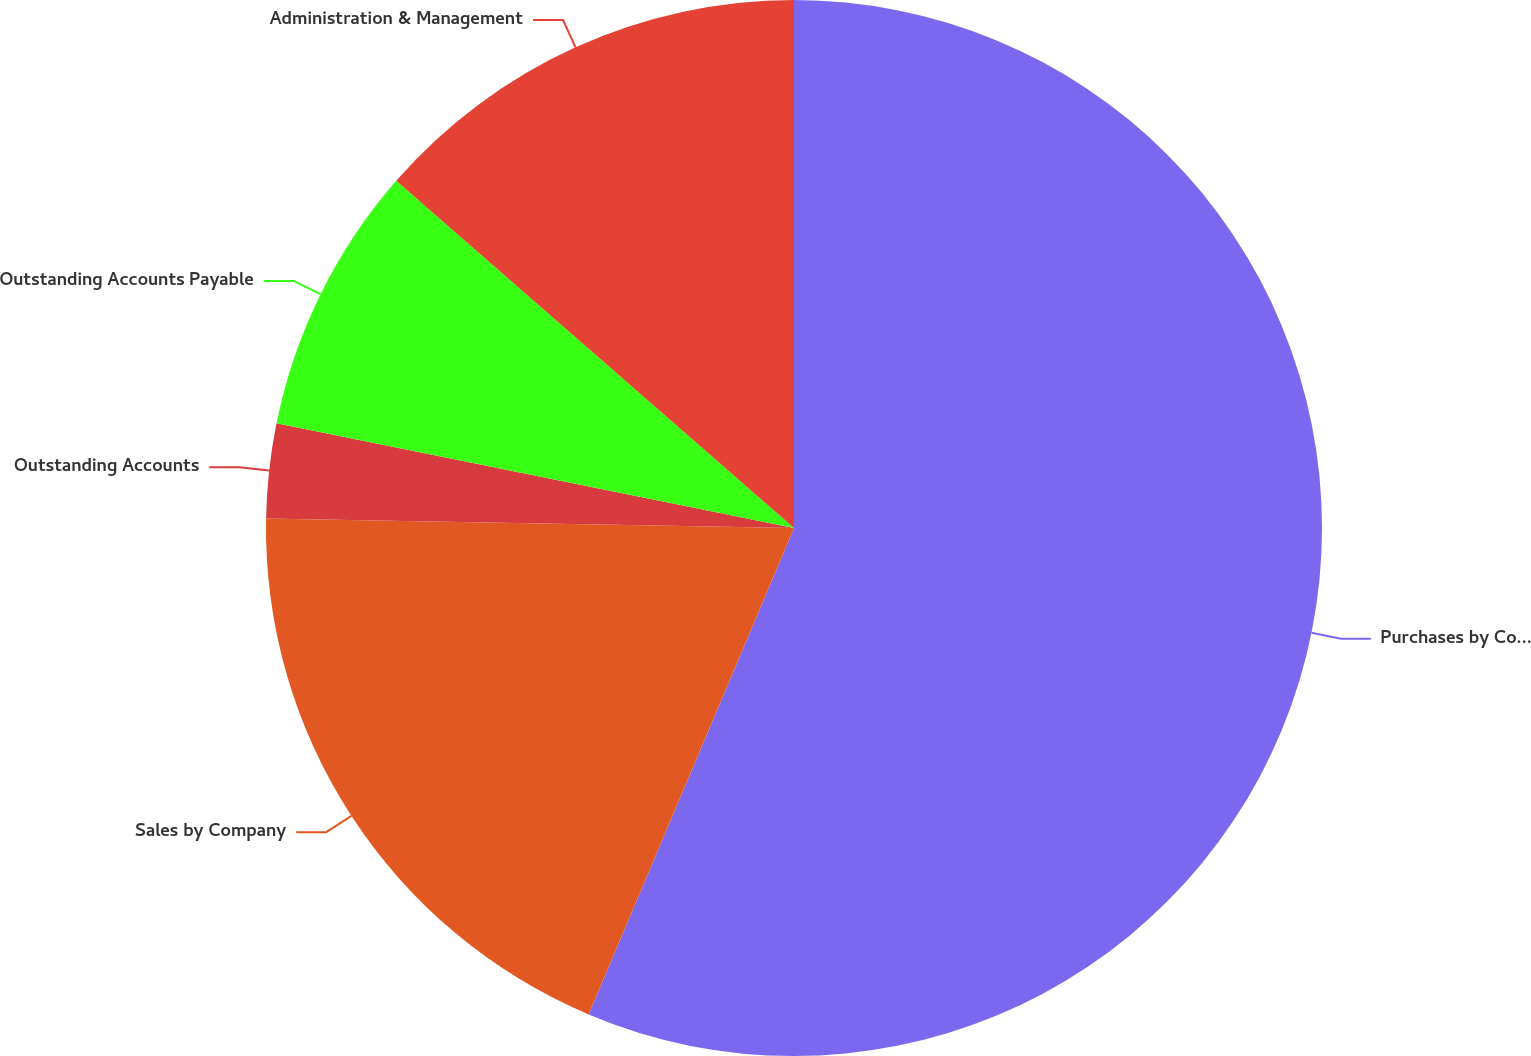Convert chart to OTSL. <chart><loc_0><loc_0><loc_500><loc_500><pie_chart><fcel>Purchases by Company<fcel>Sales by Company<fcel>Outstanding Accounts<fcel>Outstanding Accounts Payable<fcel>Administration & Management<nl><fcel>56.36%<fcel>18.93%<fcel>2.89%<fcel>8.24%<fcel>13.58%<nl></chart> 